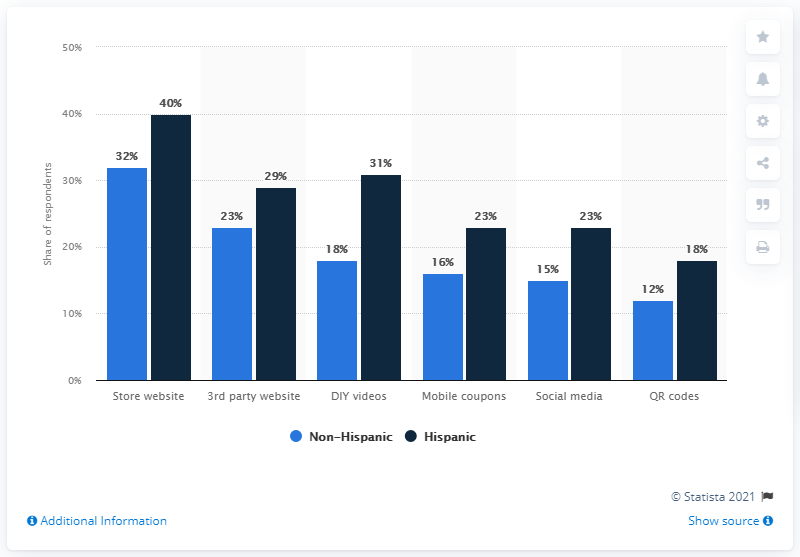Outline some significant characteristics in this image. The product with a percentage of 15% and 23% is social media. What differentiates Hispanic from non-Hispanic individuals in QR codes? 